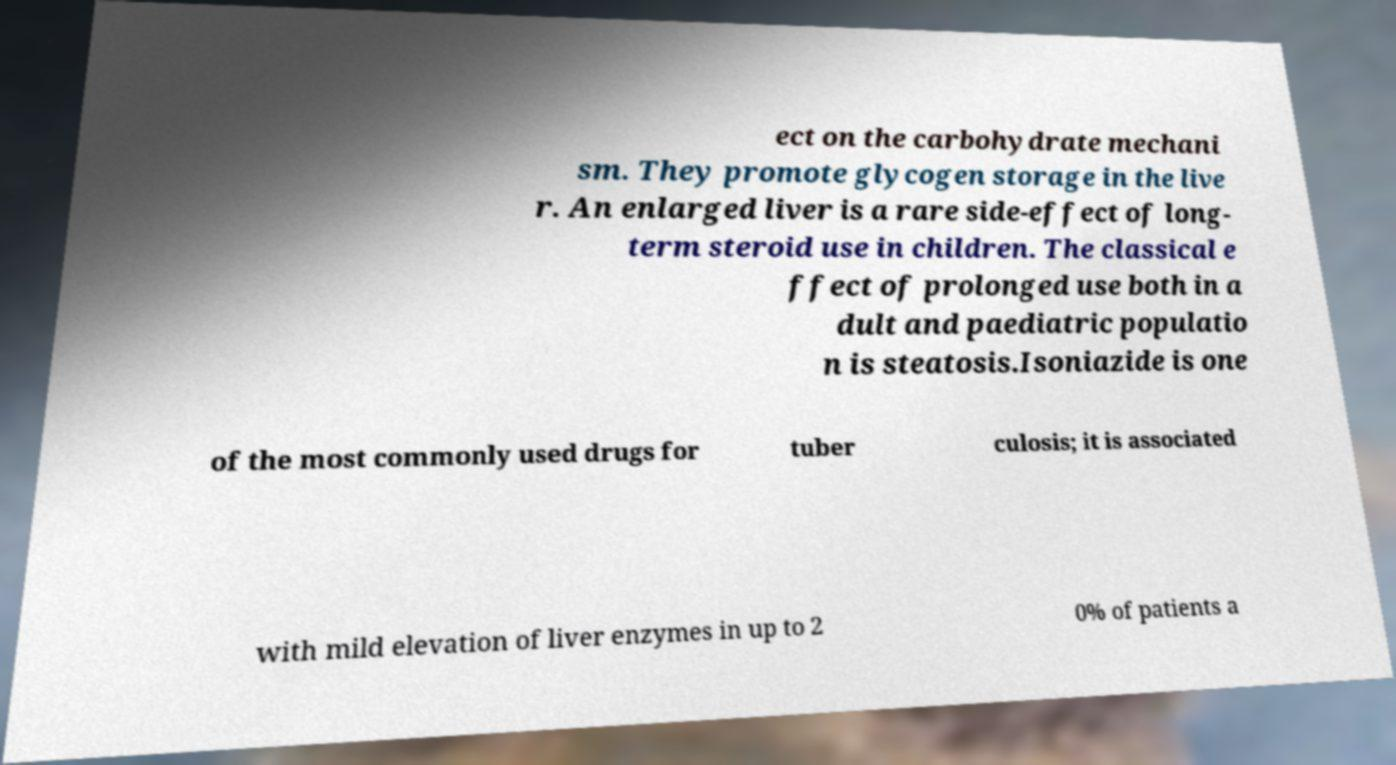Could you assist in decoding the text presented in this image and type it out clearly? ect on the carbohydrate mechani sm. They promote glycogen storage in the live r. An enlarged liver is a rare side-effect of long- term steroid use in children. The classical e ffect of prolonged use both in a dult and paediatric populatio n is steatosis.Isoniazide is one of the most commonly used drugs for tuber culosis; it is associated with mild elevation of liver enzymes in up to 2 0% of patients a 